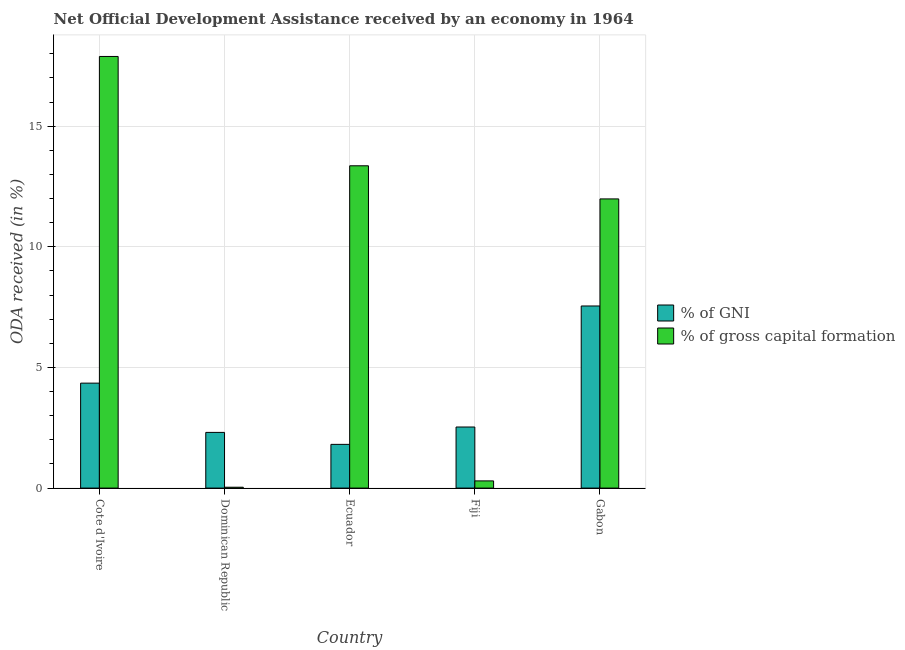Are the number of bars per tick equal to the number of legend labels?
Make the answer very short. Yes. How many bars are there on the 3rd tick from the left?
Offer a terse response. 2. How many bars are there on the 4th tick from the right?
Your answer should be compact. 2. What is the label of the 5th group of bars from the left?
Keep it short and to the point. Gabon. In how many cases, is the number of bars for a given country not equal to the number of legend labels?
Offer a terse response. 0. What is the oda received as percentage of gross capital formation in Cote d'Ivoire?
Your response must be concise. 17.89. Across all countries, what is the maximum oda received as percentage of gni?
Keep it short and to the point. 7.55. Across all countries, what is the minimum oda received as percentage of gross capital formation?
Provide a succinct answer. 0.04. In which country was the oda received as percentage of gross capital formation maximum?
Provide a succinct answer. Cote d'Ivoire. In which country was the oda received as percentage of gross capital formation minimum?
Give a very brief answer. Dominican Republic. What is the total oda received as percentage of gross capital formation in the graph?
Your answer should be very brief. 43.57. What is the difference between the oda received as percentage of gross capital formation in Fiji and that in Gabon?
Keep it short and to the point. -11.69. What is the difference between the oda received as percentage of gross capital formation in Ecuador and the oda received as percentage of gni in Dominican Republic?
Keep it short and to the point. 11.05. What is the average oda received as percentage of gni per country?
Make the answer very short. 3.71. What is the difference between the oda received as percentage of gross capital formation and oda received as percentage of gni in Fiji?
Your response must be concise. -2.23. What is the ratio of the oda received as percentage of gross capital formation in Dominican Republic to that in Ecuador?
Give a very brief answer. 0. Is the oda received as percentage of gross capital formation in Cote d'Ivoire less than that in Ecuador?
Offer a very short reply. No. Is the difference between the oda received as percentage of gni in Ecuador and Fiji greater than the difference between the oda received as percentage of gross capital formation in Ecuador and Fiji?
Offer a very short reply. No. What is the difference between the highest and the second highest oda received as percentage of gross capital formation?
Your answer should be compact. 4.53. What is the difference between the highest and the lowest oda received as percentage of gross capital formation?
Offer a terse response. 17.85. In how many countries, is the oda received as percentage of gni greater than the average oda received as percentage of gni taken over all countries?
Your response must be concise. 2. What does the 1st bar from the left in Gabon represents?
Ensure brevity in your answer.  % of GNI. What does the 2nd bar from the right in Fiji represents?
Your answer should be compact. % of GNI. How many countries are there in the graph?
Make the answer very short. 5. Are the values on the major ticks of Y-axis written in scientific E-notation?
Your answer should be very brief. No. Does the graph contain any zero values?
Your answer should be very brief. No. Does the graph contain grids?
Keep it short and to the point. Yes. Where does the legend appear in the graph?
Keep it short and to the point. Center right. What is the title of the graph?
Your answer should be compact. Net Official Development Assistance received by an economy in 1964. What is the label or title of the X-axis?
Keep it short and to the point. Country. What is the label or title of the Y-axis?
Offer a very short reply. ODA received (in %). What is the ODA received (in %) of % of GNI in Cote d'Ivoire?
Make the answer very short. 4.35. What is the ODA received (in %) in % of gross capital formation in Cote d'Ivoire?
Provide a short and direct response. 17.89. What is the ODA received (in %) in % of GNI in Dominican Republic?
Your answer should be compact. 2.31. What is the ODA received (in %) of % of gross capital formation in Dominican Republic?
Provide a short and direct response. 0.04. What is the ODA received (in %) in % of GNI in Ecuador?
Keep it short and to the point. 1.81. What is the ODA received (in %) of % of gross capital formation in Ecuador?
Make the answer very short. 13.36. What is the ODA received (in %) in % of GNI in Fiji?
Provide a succinct answer. 2.53. What is the ODA received (in %) of % of gross capital formation in Fiji?
Keep it short and to the point. 0.3. What is the ODA received (in %) in % of GNI in Gabon?
Provide a short and direct response. 7.55. What is the ODA received (in %) in % of gross capital formation in Gabon?
Make the answer very short. 11.99. Across all countries, what is the maximum ODA received (in %) of % of GNI?
Ensure brevity in your answer.  7.55. Across all countries, what is the maximum ODA received (in %) in % of gross capital formation?
Provide a short and direct response. 17.89. Across all countries, what is the minimum ODA received (in %) of % of GNI?
Your response must be concise. 1.81. Across all countries, what is the minimum ODA received (in %) in % of gross capital formation?
Ensure brevity in your answer.  0.04. What is the total ODA received (in %) of % of GNI in the graph?
Your answer should be compact. 18.55. What is the total ODA received (in %) in % of gross capital formation in the graph?
Your answer should be compact. 43.57. What is the difference between the ODA received (in %) of % of GNI in Cote d'Ivoire and that in Dominican Republic?
Make the answer very short. 2.04. What is the difference between the ODA received (in %) of % of gross capital formation in Cote d'Ivoire and that in Dominican Republic?
Provide a succinct answer. 17.85. What is the difference between the ODA received (in %) in % of GNI in Cote d'Ivoire and that in Ecuador?
Give a very brief answer. 2.54. What is the difference between the ODA received (in %) of % of gross capital formation in Cote d'Ivoire and that in Ecuador?
Make the answer very short. 4.53. What is the difference between the ODA received (in %) in % of GNI in Cote d'Ivoire and that in Fiji?
Your answer should be compact. 1.82. What is the difference between the ODA received (in %) of % of gross capital formation in Cote d'Ivoire and that in Fiji?
Provide a short and direct response. 17.59. What is the difference between the ODA received (in %) in % of GNI in Cote d'Ivoire and that in Gabon?
Keep it short and to the point. -3.2. What is the difference between the ODA received (in %) of % of gross capital formation in Cote d'Ivoire and that in Gabon?
Your response must be concise. 5.9. What is the difference between the ODA received (in %) of % of GNI in Dominican Republic and that in Ecuador?
Provide a succinct answer. 0.5. What is the difference between the ODA received (in %) in % of gross capital formation in Dominican Republic and that in Ecuador?
Your answer should be very brief. -13.32. What is the difference between the ODA received (in %) of % of GNI in Dominican Republic and that in Fiji?
Your answer should be compact. -0.22. What is the difference between the ODA received (in %) of % of gross capital formation in Dominican Republic and that in Fiji?
Give a very brief answer. -0.26. What is the difference between the ODA received (in %) of % of GNI in Dominican Republic and that in Gabon?
Your answer should be compact. -5.24. What is the difference between the ODA received (in %) in % of gross capital formation in Dominican Republic and that in Gabon?
Your answer should be compact. -11.95. What is the difference between the ODA received (in %) of % of GNI in Ecuador and that in Fiji?
Keep it short and to the point. -0.72. What is the difference between the ODA received (in %) in % of gross capital formation in Ecuador and that in Fiji?
Ensure brevity in your answer.  13.06. What is the difference between the ODA received (in %) in % of GNI in Ecuador and that in Gabon?
Your response must be concise. -5.74. What is the difference between the ODA received (in %) of % of gross capital formation in Ecuador and that in Gabon?
Offer a terse response. 1.37. What is the difference between the ODA received (in %) in % of GNI in Fiji and that in Gabon?
Provide a short and direct response. -5.02. What is the difference between the ODA received (in %) of % of gross capital formation in Fiji and that in Gabon?
Ensure brevity in your answer.  -11.69. What is the difference between the ODA received (in %) in % of GNI in Cote d'Ivoire and the ODA received (in %) in % of gross capital formation in Dominican Republic?
Ensure brevity in your answer.  4.31. What is the difference between the ODA received (in %) in % of GNI in Cote d'Ivoire and the ODA received (in %) in % of gross capital formation in Ecuador?
Your response must be concise. -9.01. What is the difference between the ODA received (in %) of % of GNI in Cote d'Ivoire and the ODA received (in %) of % of gross capital formation in Fiji?
Give a very brief answer. 4.05. What is the difference between the ODA received (in %) in % of GNI in Cote d'Ivoire and the ODA received (in %) in % of gross capital formation in Gabon?
Offer a terse response. -7.64. What is the difference between the ODA received (in %) in % of GNI in Dominican Republic and the ODA received (in %) in % of gross capital formation in Ecuador?
Ensure brevity in your answer.  -11.05. What is the difference between the ODA received (in %) in % of GNI in Dominican Republic and the ODA received (in %) in % of gross capital formation in Fiji?
Offer a terse response. 2.01. What is the difference between the ODA received (in %) in % of GNI in Dominican Republic and the ODA received (in %) in % of gross capital formation in Gabon?
Your answer should be very brief. -9.68. What is the difference between the ODA received (in %) in % of GNI in Ecuador and the ODA received (in %) in % of gross capital formation in Fiji?
Keep it short and to the point. 1.51. What is the difference between the ODA received (in %) of % of GNI in Ecuador and the ODA received (in %) of % of gross capital formation in Gabon?
Give a very brief answer. -10.17. What is the difference between the ODA received (in %) in % of GNI in Fiji and the ODA received (in %) in % of gross capital formation in Gabon?
Your answer should be very brief. -9.45. What is the average ODA received (in %) of % of GNI per country?
Ensure brevity in your answer.  3.71. What is the average ODA received (in %) of % of gross capital formation per country?
Make the answer very short. 8.71. What is the difference between the ODA received (in %) of % of GNI and ODA received (in %) of % of gross capital formation in Cote d'Ivoire?
Give a very brief answer. -13.54. What is the difference between the ODA received (in %) in % of GNI and ODA received (in %) in % of gross capital formation in Dominican Republic?
Keep it short and to the point. 2.27. What is the difference between the ODA received (in %) of % of GNI and ODA received (in %) of % of gross capital formation in Ecuador?
Keep it short and to the point. -11.55. What is the difference between the ODA received (in %) in % of GNI and ODA received (in %) in % of gross capital formation in Fiji?
Give a very brief answer. 2.23. What is the difference between the ODA received (in %) in % of GNI and ODA received (in %) in % of gross capital formation in Gabon?
Offer a terse response. -4.44. What is the ratio of the ODA received (in %) in % of GNI in Cote d'Ivoire to that in Dominican Republic?
Your answer should be compact. 1.88. What is the ratio of the ODA received (in %) in % of gross capital formation in Cote d'Ivoire to that in Dominican Republic?
Offer a very short reply. 498.6. What is the ratio of the ODA received (in %) in % of GNI in Cote d'Ivoire to that in Ecuador?
Your response must be concise. 2.4. What is the ratio of the ODA received (in %) of % of gross capital formation in Cote d'Ivoire to that in Ecuador?
Keep it short and to the point. 1.34. What is the ratio of the ODA received (in %) in % of GNI in Cote d'Ivoire to that in Fiji?
Make the answer very short. 1.72. What is the ratio of the ODA received (in %) in % of gross capital formation in Cote d'Ivoire to that in Fiji?
Your response must be concise. 59.98. What is the ratio of the ODA received (in %) in % of GNI in Cote d'Ivoire to that in Gabon?
Give a very brief answer. 0.58. What is the ratio of the ODA received (in %) in % of gross capital formation in Cote d'Ivoire to that in Gabon?
Provide a succinct answer. 1.49. What is the ratio of the ODA received (in %) of % of GNI in Dominican Republic to that in Ecuador?
Your response must be concise. 1.27. What is the ratio of the ODA received (in %) of % of gross capital formation in Dominican Republic to that in Ecuador?
Your answer should be very brief. 0. What is the ratio of the ODA received (in %) in % of GNI in Dominican Republic to that in Fiji?
Make the answer very short. 0.91. What is the ratio of the ODA received (in %) of % of gross capital formation in Dominican Republic to that in Fiji?
Make the answer very short. 0.12. What is the ratio of the ODA received (in %) in % of GNI in Dominican Republic to that in Gabon?
Provide a short and direct response. 0.31. What is the ratio of the ODA received (in %) in % of gross capital formation in Dominican Republic to that in Gabon?
Provide a succinct answer. 0. What is the ratio of the ODA received (in %) in % of GNI in Ecuador to that in Fiji?
Offer a very short reply. 0.72. What is the ratio of the ODA received (in %) in % of gross capital formation in Ecuador to that in Fiji?
Ensure brevity in your answer.  44.79. What is the ratio of the ODA received (in %) of % of GNI in Ecuador to that in Gabon?
Make the answer very short. 0.24. What is the ratio of the ODA received (in %) in % of gross capital formation in Ecuador to that in Gabon?
Ensure brevity in your answer.  1.11. What is the ratio of the ODA received (in %) in % of GNI in Fiji to that in Gabon?
Your answer should be very brief. 0.34. What is the ratio of the ODA received (in %) in % of gross capital formation in Fiji to that in Gabon?
Offer a terse response. 0.02. What is the difference between the highest and the second highest ODA received (in %) in % of GNI?
Make the answer very short. 3.2. What is the difference between the highest and the second highest ODA received (in %) of % of gross capital formation?
Offer a very short reply. 4.53. What is the difference between the highest and the lowest ODA received (in %) of % of GNI?
Make the answer very short. 5.74. What is the difference between the highest and the lowest ODA received (in %) of % of gross capital formation?
Your response must be concise. 17.85. 